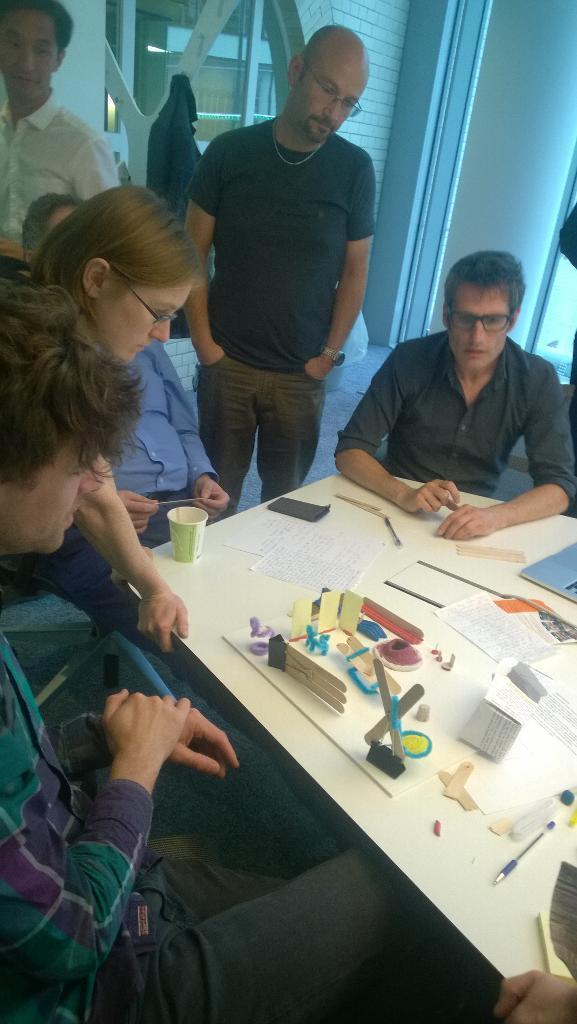Please provide a concise description of this image. In this image, There is a table which is in white color on that table there is a glass, There are some papers which are in white color, There are some objects kept on the table, There are some people sitting on the chairs around the table, In the middle there is a man standing, In the background there is a white color wall and there is a glass door. 